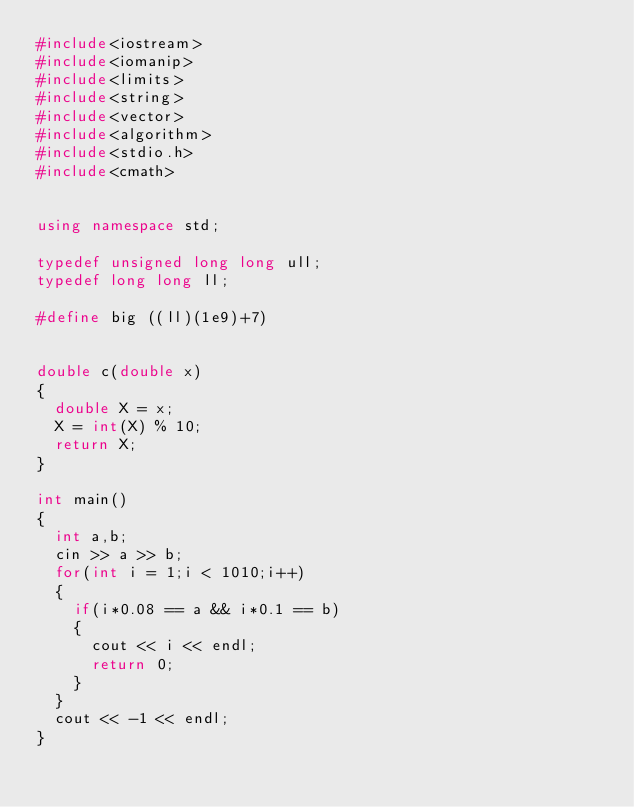Convert code to text. <code><loc_0><loc_0><loc_500><loc_500><_C++_>#include<iostream>
#include<iomanip>
#include<limits>
#include<string>
#include<vector>
#include<algorithm>
#include<stdio.h>
#include<cmath>


using namespace std;

typedef unsigned long long ull;
typedef long long ll;

#define big ((ll)(1e9)+7)


double c(double x)
{
  double X = x;
  X = int(X) % 10;
  return X;
}

int main()
{
  int a,b;
  cin >> a >> b;
  for(int i = 1;i < 1010;i++)
  {
    if(i*0.08 == a && i*0.1 == b)
    {
      cout << i << endl;
      return 0;
    }
  }
  cout << -1 << endl;
}
</code> 